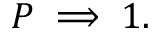<formula> <loc_0><loc_0><loc_500><loc_500>P \implies 1 .</formula> 